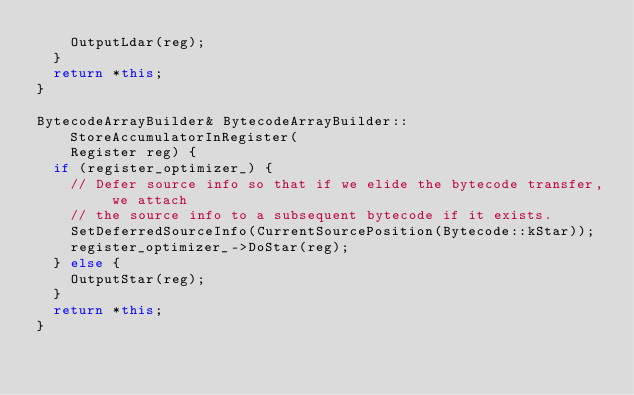Convert code to text. <code><loc_0><loc_0><loc_500><loc_500><_C++_>    OutputLdar(reg);
  }
  return *this;
}

BytecodeArrayBuilder& BytecodeArrayBuilder::StoreAccumulatorInRegister(
    Register reg) {
  if (register_optimizer_) {
    // Defer source info so that if we elide the bytecode transfer, we attach
    // the source info to a subsequent bytecode if it exists.
    SetDeferredSourceInfo(CurrentSourcePosition(Bytecode::kStar));
    register_optimizer_->DoStar(reg);
  } else {
    OutputStar(reg);
  }
  return *this;
}
</code> 